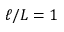Convert formula to latex. <formula><loc_0><loc_0><loc_500><loc_500>\ell / L = 1</formula> 